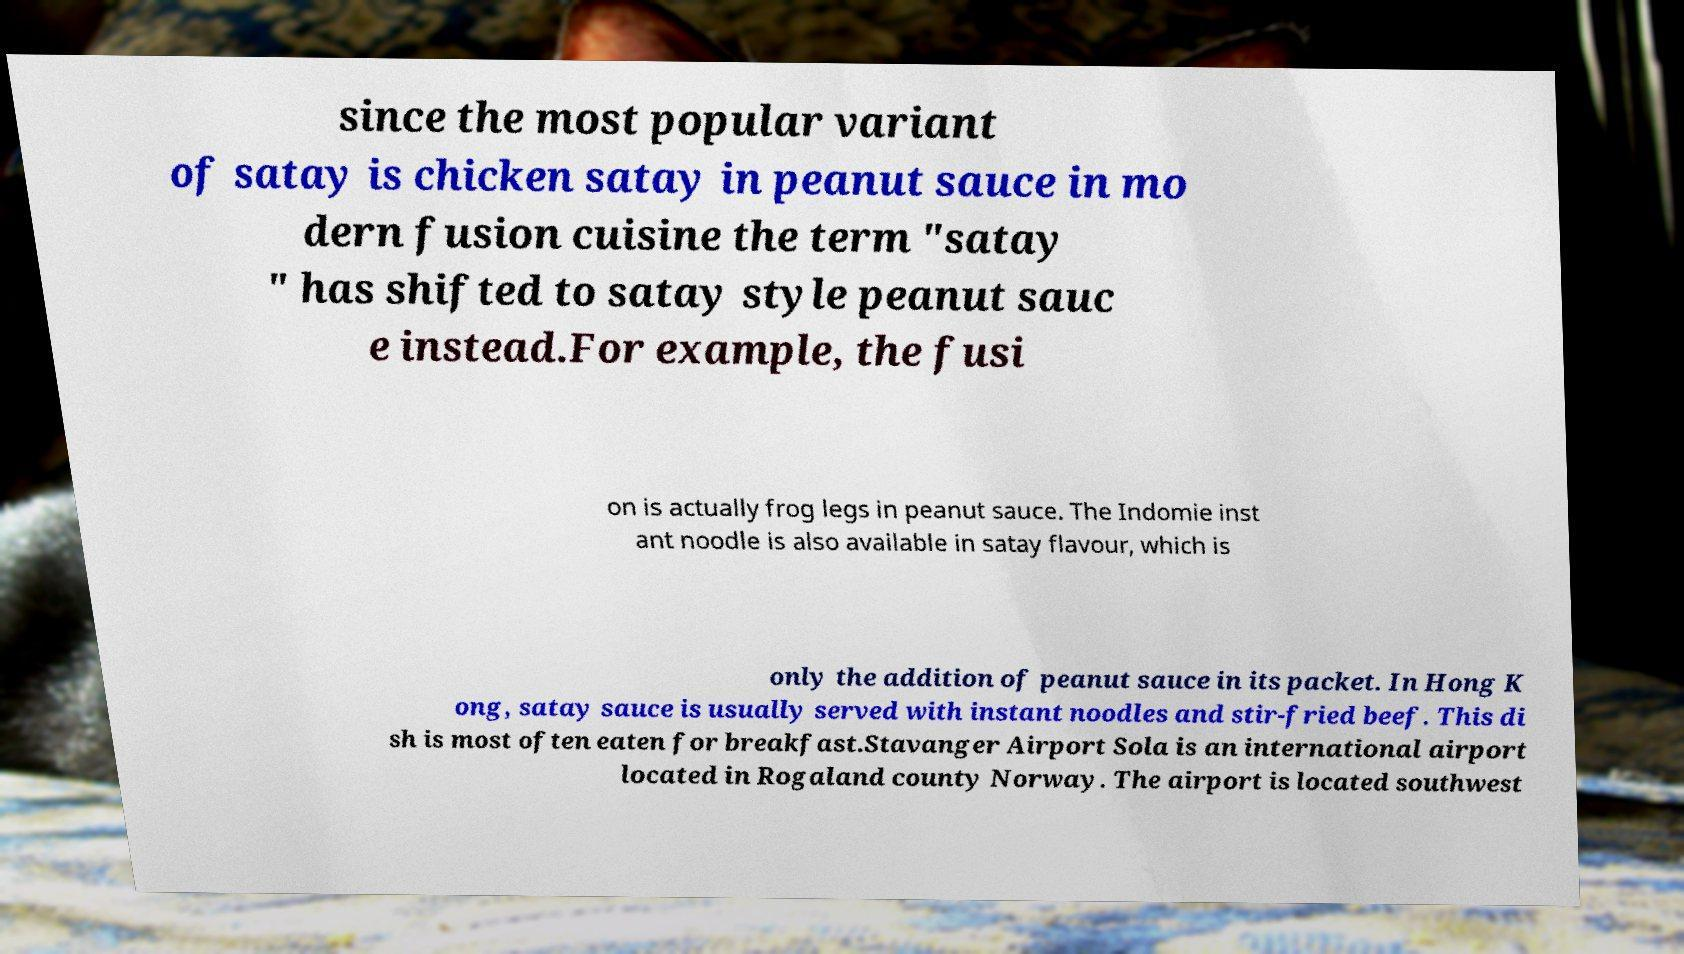Please identify and transcribe the text found in this image. since the most popular variant of satay is chicken satay in peanut sauce in mo dern fusion cuisine the term "satay " has shifted to satay style peanut sauc e instead.For example, the fusi on is actually frog legs in peanut sauce. The Indomie inst ant noodle is also available in satay flavour, which is only the addition of peanut sauce in its packet. In Hong K ong, satay sauce is usually served with instant noodles and stir-fried beef. This di sh is most often eaten for breakfast.Stavanger Airport Sola is an international airport located in Rogaland county Norway. The airport is located southwest 